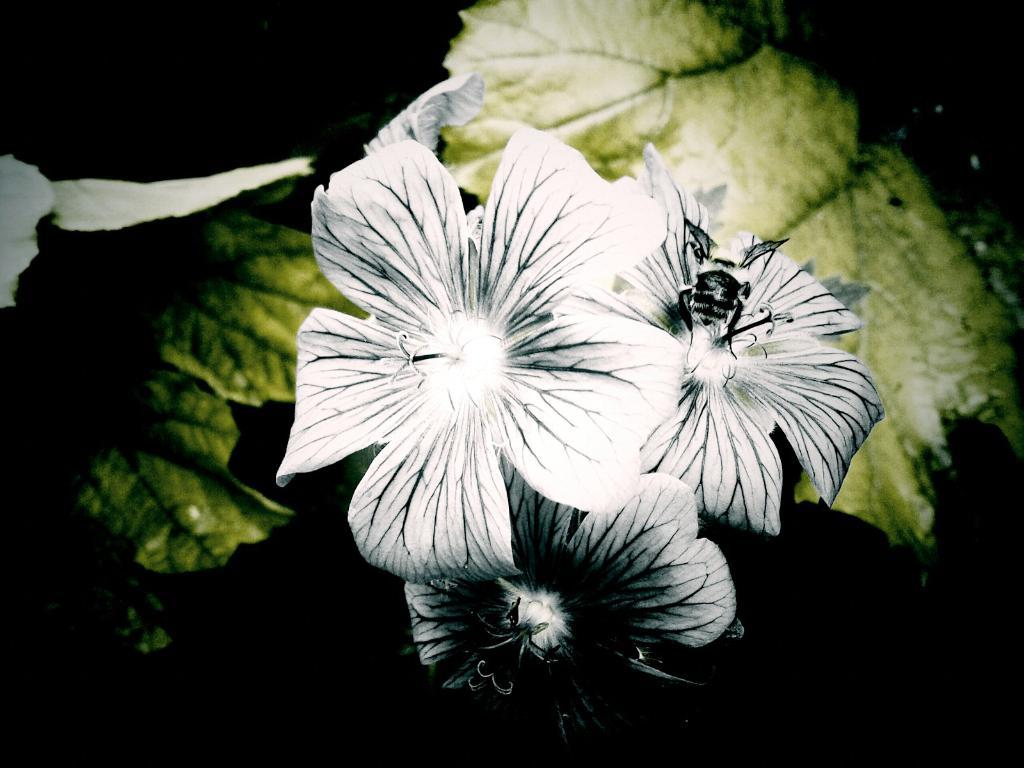What type of plant material is present in the image? There are leaves in the image. How many flowers can be seen in the image? There are three flowers in the image. What color are the flowers? The flowers are white in color. Are there any distinguishing features on the flowers? Yes, the flowers have black lines on them. How many ducks are swimming in the water near the flowers in the image? There are no ducks or water present in the image; it only features leaves and flowers. 